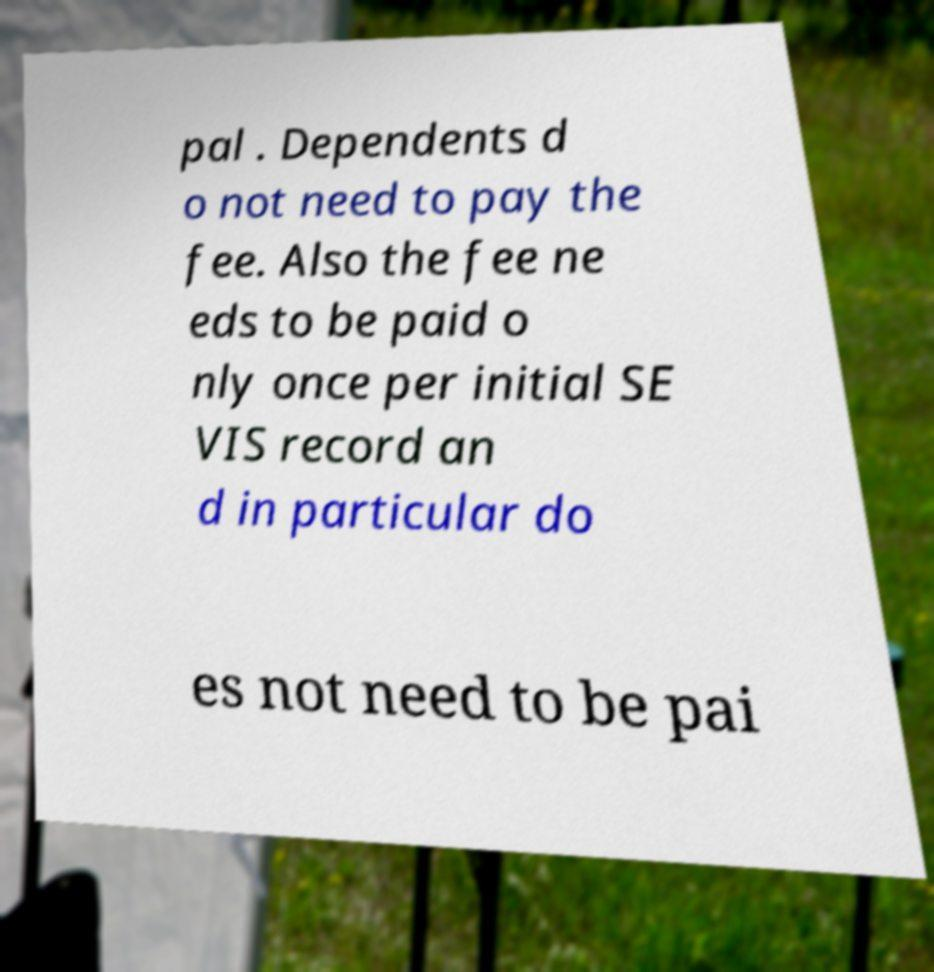There's text embedded in this image that I need extracted. Can you transcribe it verbatim? pal . Dependents d o not need to pay the fee. Also the fee ne eds to be paid o nly once per initial SE VIS record an d in particular do es not need to be pai 